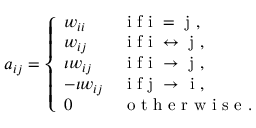<formula> <loc_0><loc_0><loc_500><loc_500>a _ { i j } = \left \{ \begin{array} { l l } { w _ { i i } } & { i f i = j , } \\ { w _ { i j } } & { i f i \leftrightarrow j , } \\ { \iota w _ { i j } } & { i f i \rightarrow j , } \\ { - \iota w _ { i j } } & { i f j \rightarrow i , } \\ { 0 } & { o t h e r w i s e . } \end{array}</formula> 